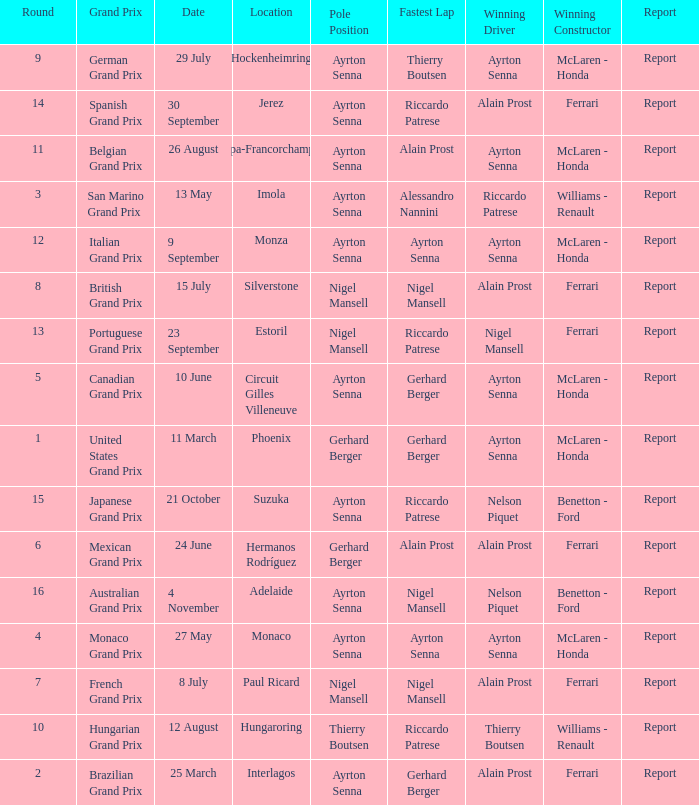What is the date that Ayrton Senna was the drive in Monza? 9 September. 